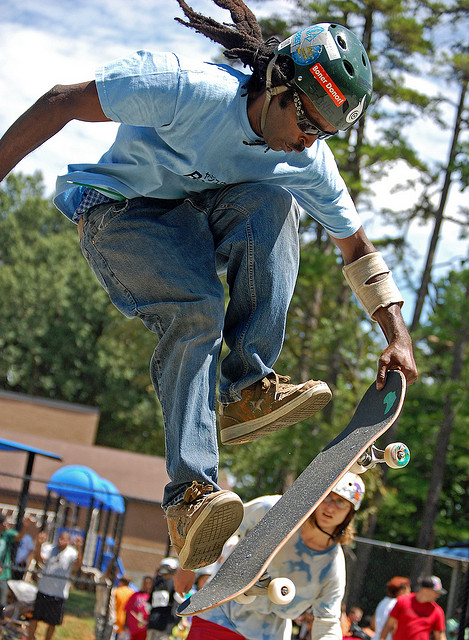<image>Who is on the kids hat? I don't know who is on the kids hat. It could be 'flyers', 'tony hawk', 'animal', 'ninja turtle', 'stickers' or 'groot'. Who is on the kids hat? I don't know who is on the kid's hat. It can be any of the options mentioned. 